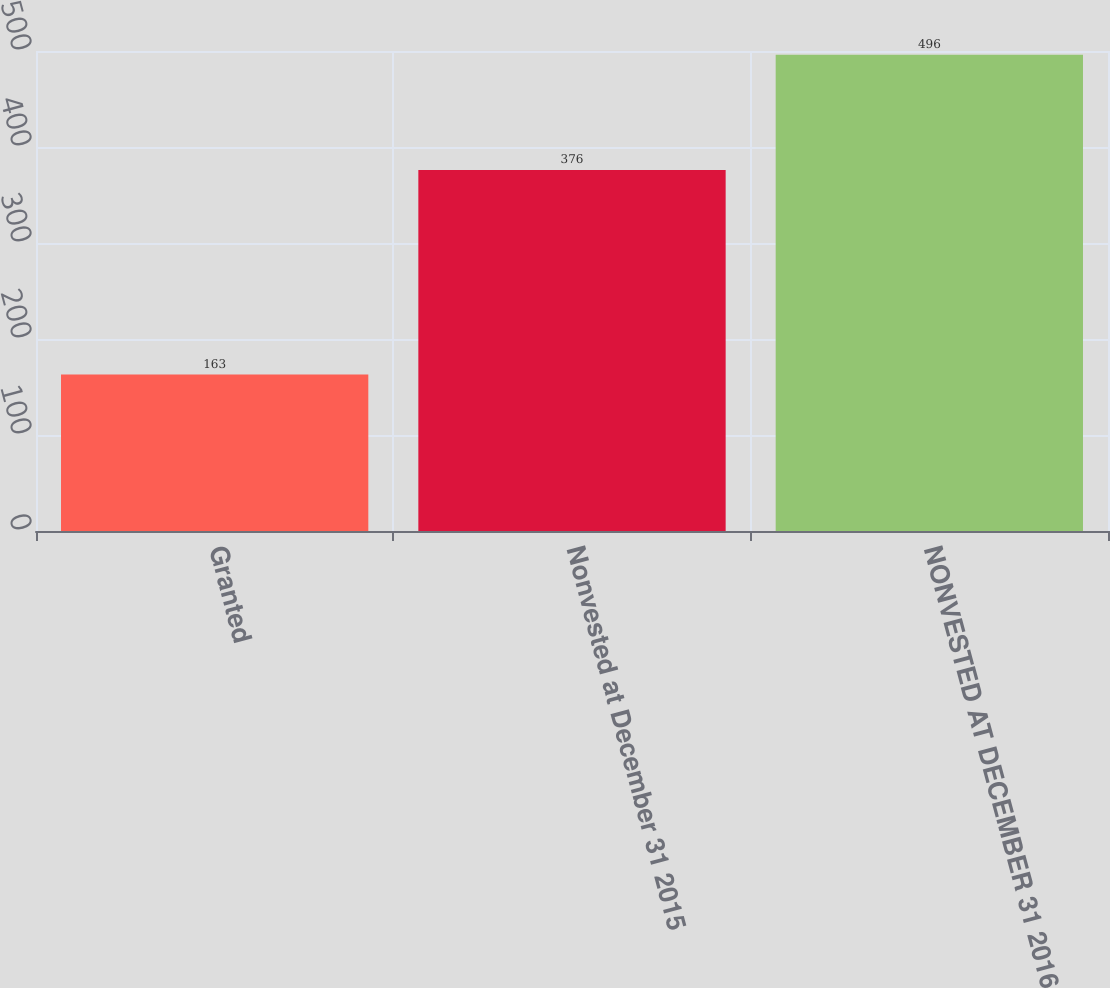<chart> <loc_0><loc_0><loc_500><loc_500><bar_chart><fcel>Granted<fcel>Nonvested at December 31 2015<fcel>NONVESTED AT DECEMBER 31 2016<nl><fcel>163<fcel>376<fcel>496<nl></chart> 